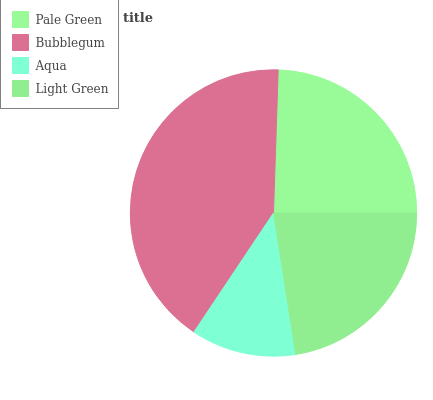Is Aqua the minimum?
Answer yes or no. Yes. Is Bubblegum the maximum?
Answer yes or no. Yes. Is Bubblegum the minimum?
Answer yes or no. No. Is Aqua the maximum?
Answer yes or no. No. Is Bubblegum greater than Aqua?
Answer yes or no. Yes. Is Aqua less than Bubblegum?
Answer yes or no. Yes. Is Aqua greater than Bubblegum?
Answer yes or no. No. Is Bubblegum less than Aqua?
Answer yes or no. No. Is Pale Green the high median?
Answer yes or no. Yes. Is Light Green the low median?
Answer yes or no. Yes. Is Bubblegum the high median?
Answer yes or no. No. Is Bubblegum the low median?
Answer yes or no. No. 